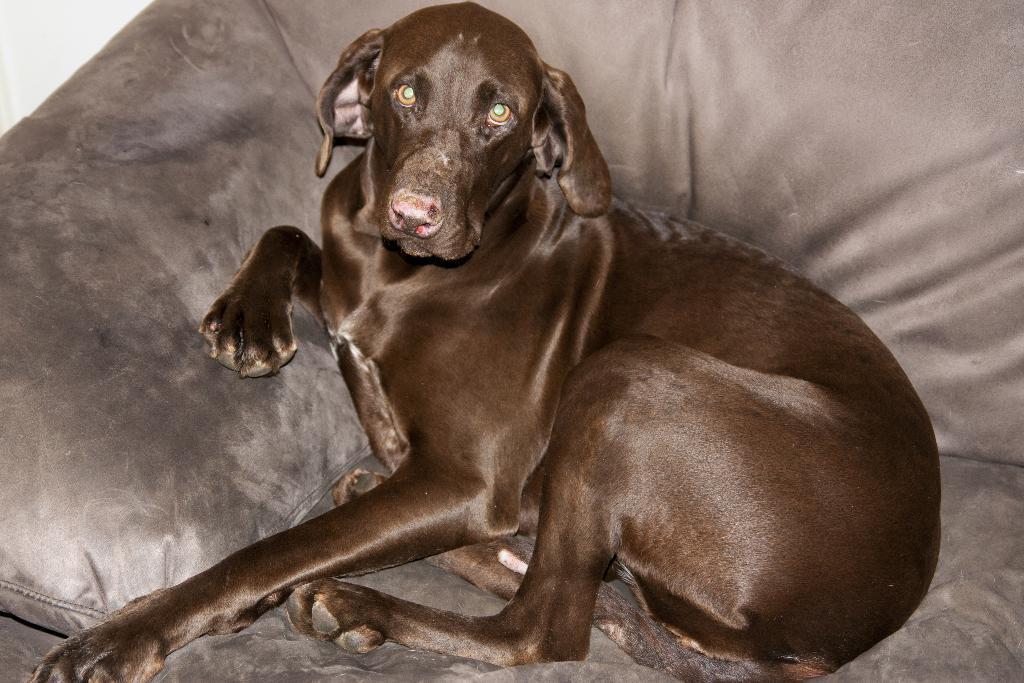How would you summarize this image in a sentence or two? In this picture there is a black dog who is sitting on the couch. In the top left corner there is a wall. 